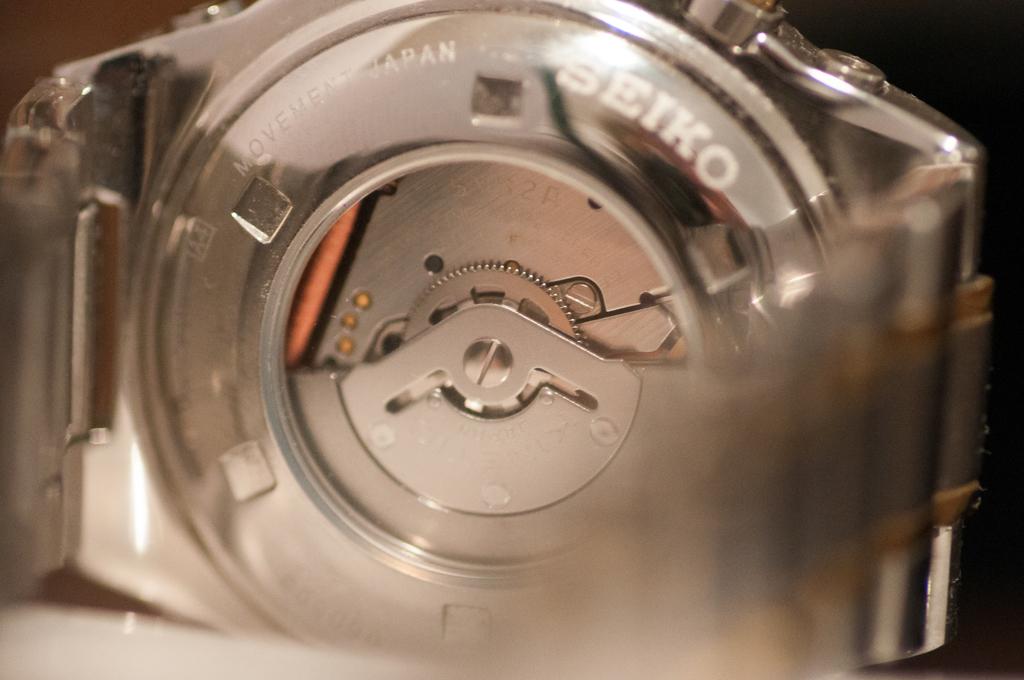What brand of watch is this?
Offer a very short reply. Seiko. 